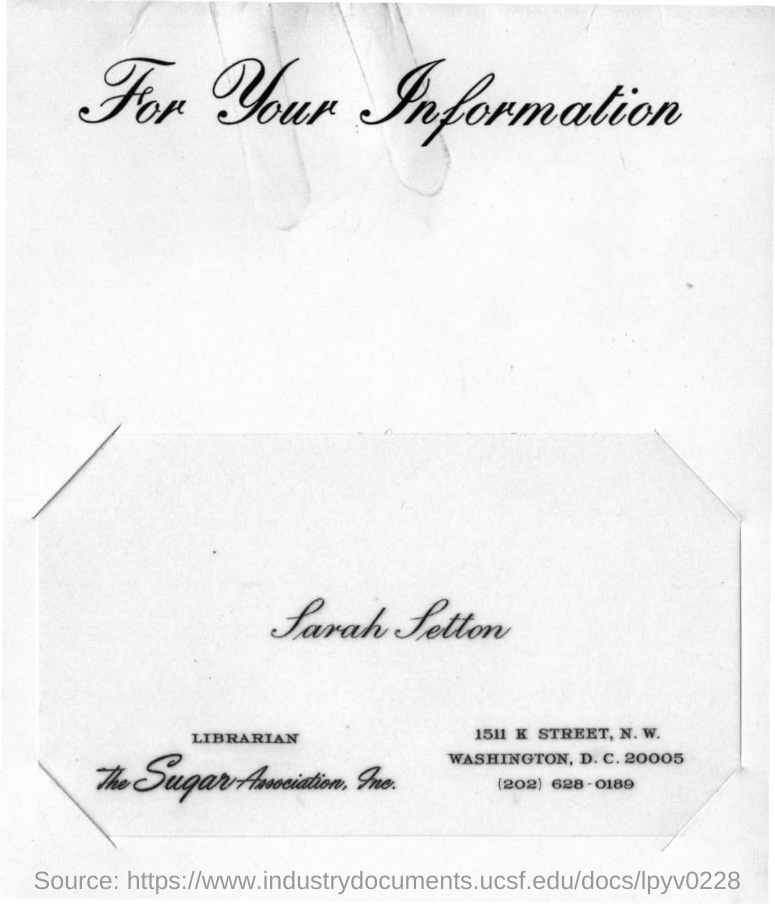Who is the librarian of The Sugar Association, Inc?
Your answer should be very brief. Sarah Setton. 